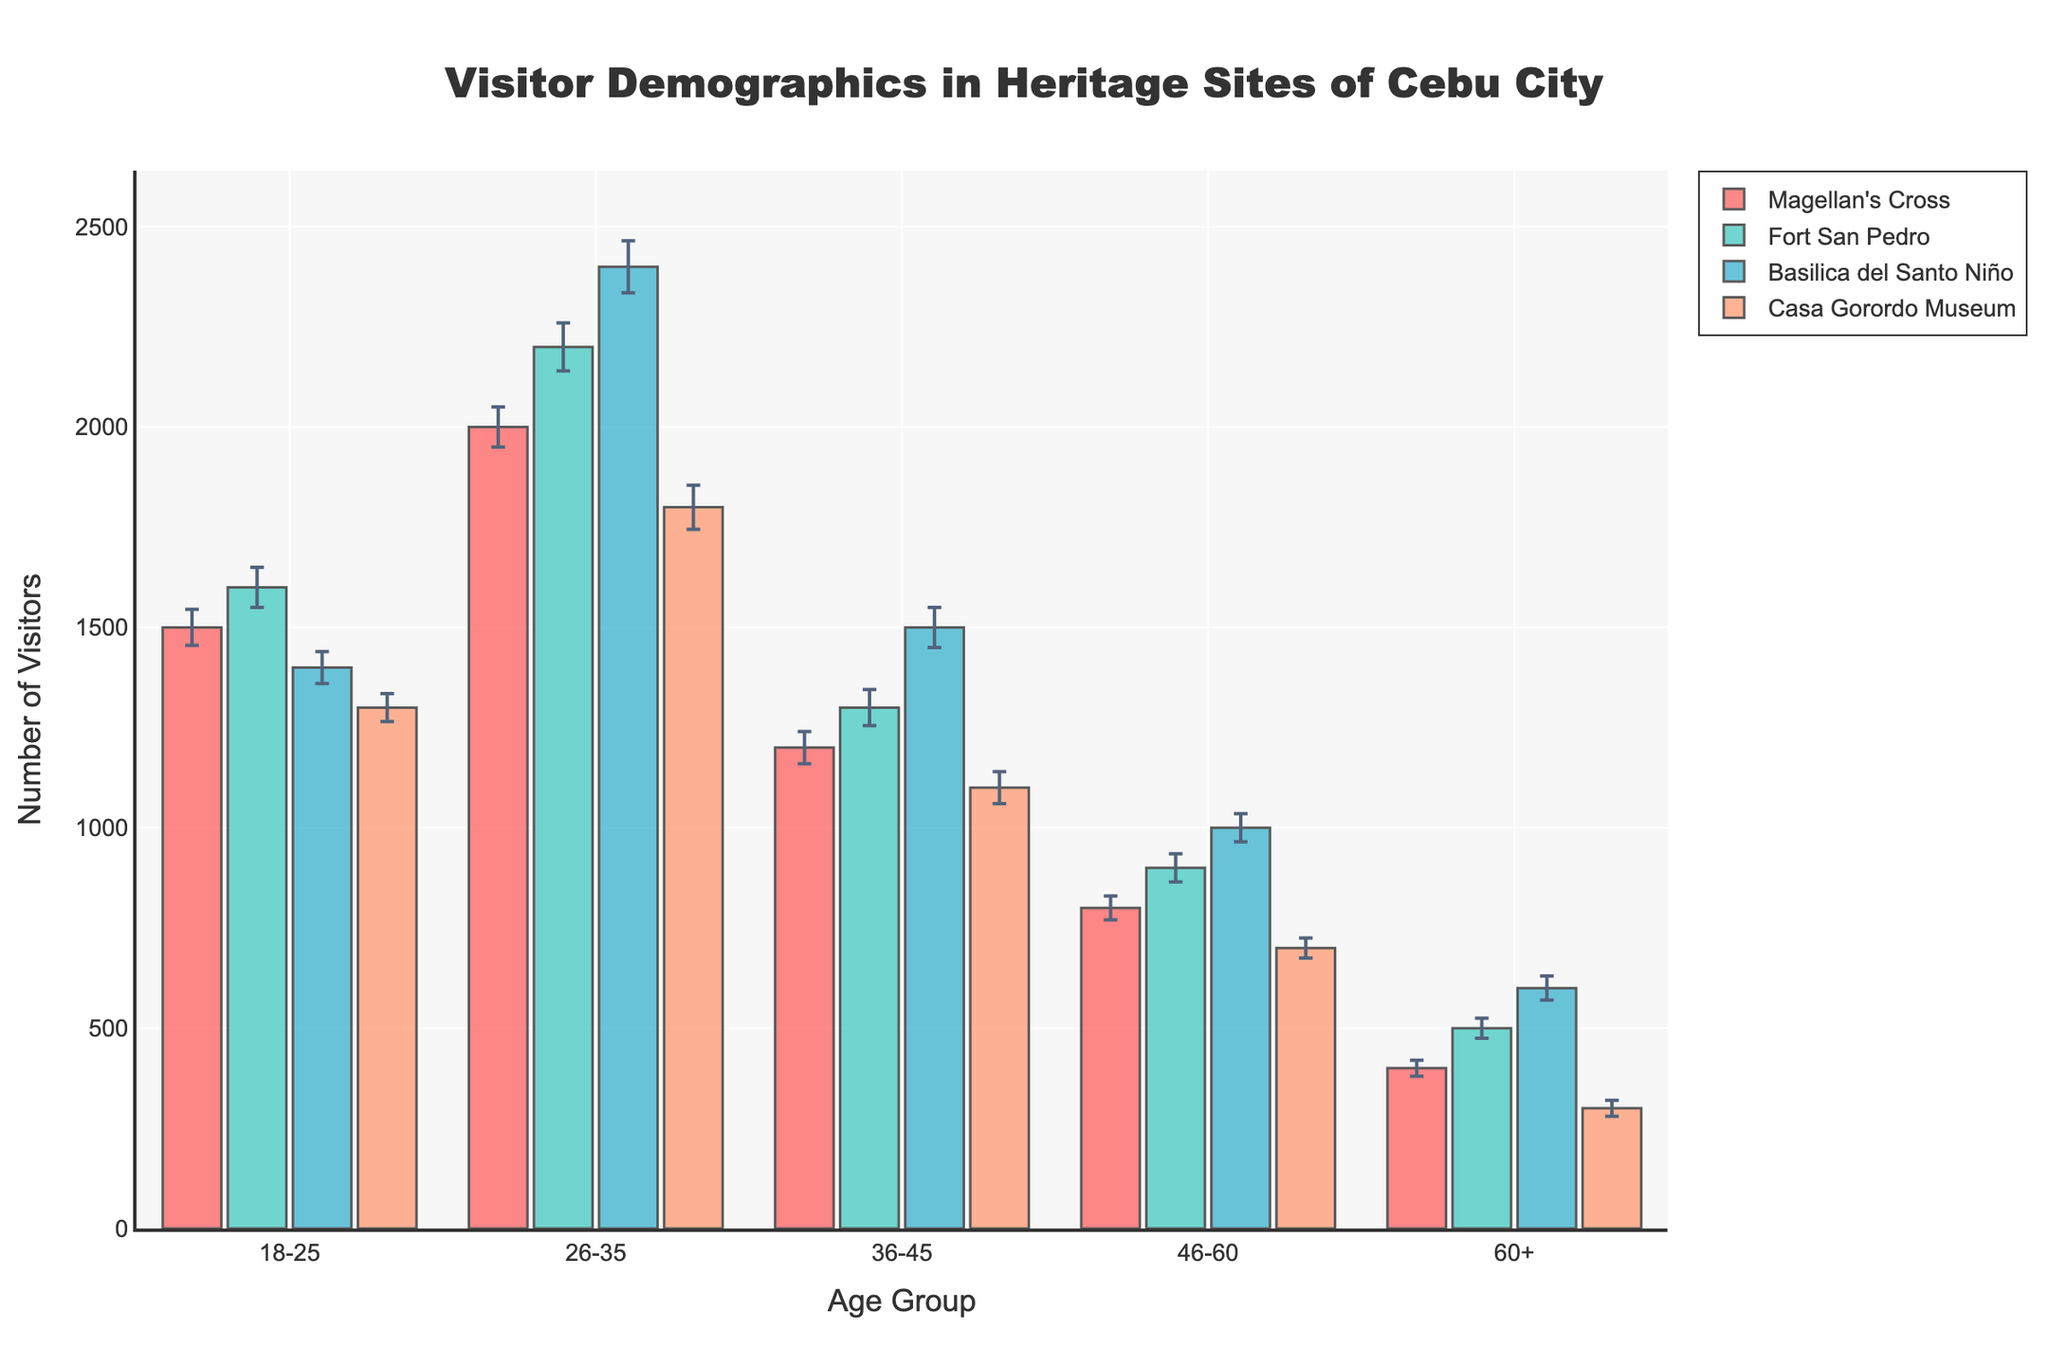Do all heritage sites have the same number of visitors in the age group 18-25? Check the bar heights for the age group 18-25 for each heritage site. They are: Magellan's Cross (1500), Fort San Pedro (1600), Basilica del Santo Niño (1400), and Casa Gorordo Museum (1300). These numbers differ.
Answer: No What is the total number of visitors aged 36-45 across all heritage sites? Add visitors aged 36-45 for each site: Magellan's Cross (1200), Fort San Pedro (1300), Basilica del Santo Niño (1500), and Casa Gorordo Museum (1100). Sum = 1200 + 1300 + 1500 + 1100 = 5100.
Answer: 5100 Which heritage site has the largest standard error for the 26-35 age group? Compare the standard errors for the 26-35 age group: Magellan's Cross (50), Fort San Pedro (60), Basilica del Santo Niño (65), and Casa Gorordo Museum (55). The largest is Basilica del Santo Niño with 65.
Answer: Basilica del Santo Niño For the 60+ age group, which heritage site has the least number of visitors? Compare the number of visitors for the 60+ age group: Magellan's Cross (400), Fort San Pedro (500), Basilica del Santo Niño (600), and Casa Gorordo Museum (300). The least is Casa Gorordo Museum with 300.
Answer: Casa Gorordo Museum How many more visitors does Fort San Pedro have compared to Casa Gorordo Museum in the 26-35 age group? Subtract the number of visitors of Casa Gorordo Museum in this age group (1800) from those of Fort San Pedro (2200). 2200 - 1800 = 400.
Answer: 400 Which age group has the most visitors in Magellan's Cross? Compare the visitor numbers for all age groups in Magellan's Cross. The highest is for the 26-35 age group with 2000 visitors.
Answer: 26-35 Which heritage site has the highest overall number of visitors in the 46-60 age group? Compare visitor numbers for the 46-60 age group in all heritage sites: Magellan's Cross (800), Fort San Pedro (900), Basilica del Santo Niño (1000), Casa Gorordo Museum (700). The highest is Basilica del Santo Niño with 1000.
Answer: Basilica del Santo Niño Does Basilica del Santo Niño have more visitors in the age group 18-25 or the age group 60+? Compare the visitor numbers for these two age groups: 18-25 (1400) and 60+ (600) for Basilica del Santo Niño. 1400 is greater than 600.
Answer: 18-25 What is the average number of visitors aged 46-60 across all heritage sites? Add the visitor numbers for this age group and divide by the number of sites: (800 + 900 + 1000 + 700) / 4 = 3400 / 4 = 850.
Answer: 850 